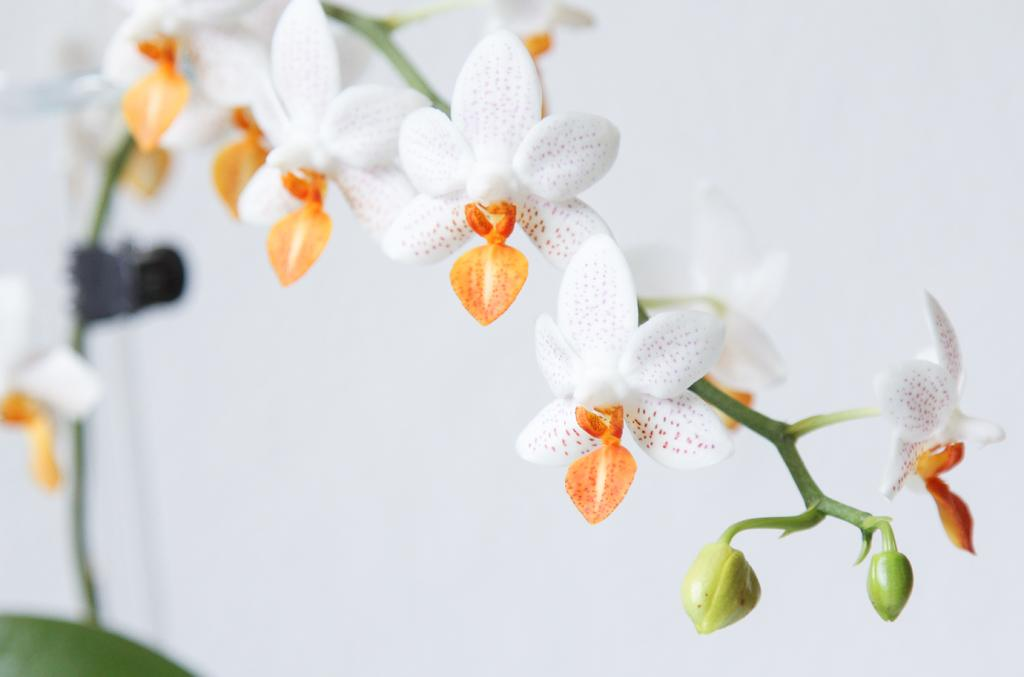What color are the flowers in the image? The flowers in the image are white. Are there any cherries or lettuce visible in the image? There are no cherries or lettuce present in the image; it only features white color flowers. 